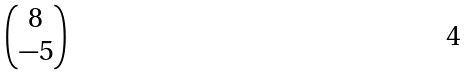Convert formula to latex. <formula><loc_0><loc_0><loc_500><loc_500>\begin{pmatrix} 8 \\ - 5 \end{pmatrix}</formula> 